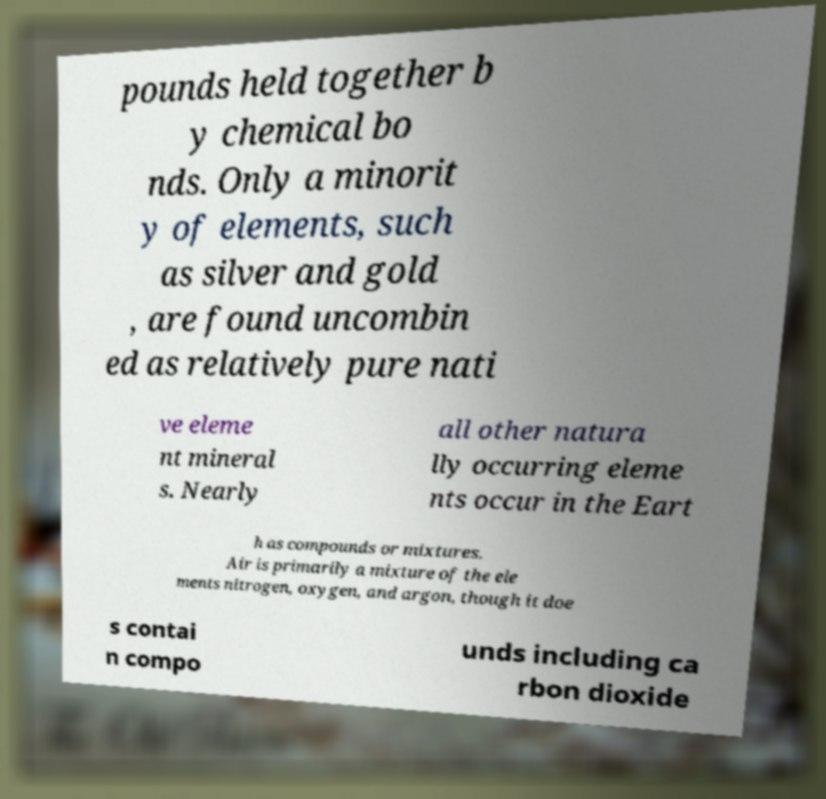For documentation purposes, I need the text within this image transcribed. Could you provide that? pounds held together b y chemical bo nds. Only a minorit y of elements, such as silver and gold , are found uncombin ed as relatively pure nati ve eleme nt mineral s. Nearly all other natura lly occurring eleme nts occur in the Eart h as compounds or mixtures. Air is primarily a mixture of the ele ments nitrogen, oxygen, and argon, though it doe s contai n compo unds including ca rbon dioxide 